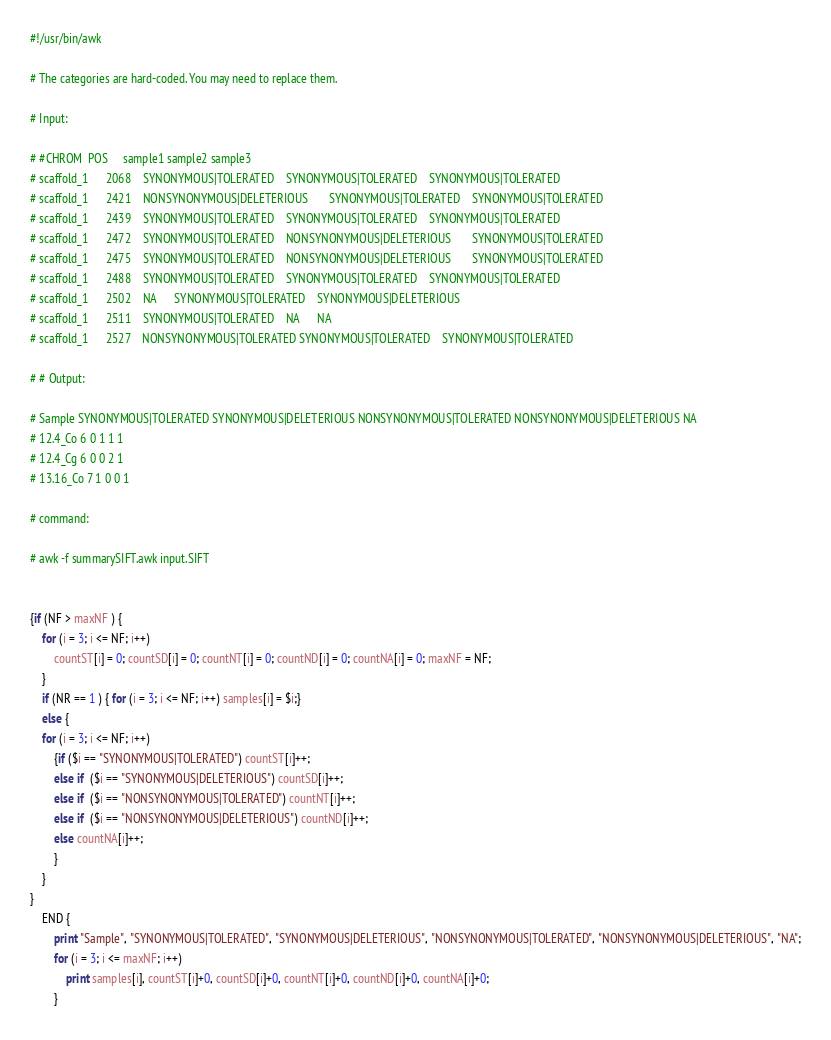<code> <loc_0><loc_0><loc_500><loc_500><_Awk_>#!/usr/bin/awk

# The categories are hard-coded. You may need to replace them.

# Input:

# #CHROM  POS     sample1 sample2 sample3
# scaffold_1      2068    SYNONYMOUS|TOLERATED    SYNONYMOUS|TOLERATED    SYNONYMOUS|TOLERATED
# scaffold_1      2421    NONSYNONYMOUS|DELETERIOUS       SYNONYMOUS|TOLERATED    SYNONYMOUS|TOLERATED
# scaffold_1      2439    SYNONYMOUS|TOLERATED    SYNONYMOUS|TOLERATED    SYNONYMOUS|TOLERATED
# scaffold_1      2472    SYNONYMOUS|TOLERATED    NONSYNONYMOUS|DELETERIOUS       SYNONYMOUS|TOLERATED
# scaffold_1      2475    SYNONYMOUS|TOLERATED    NONSYNONYMOUS|DELETERIOUS       SYNONYMOUS|TOLERATED
# scaffold_1      2488    SYNONYMOUS|TOLERATED    SYNONYMOUS|TOLERATED    SYNONYMOUS|TOLERATED
# scaffold_1      2502    NA      SYNONYMOUS|TOLERATED    SYNONYMOUS|DELETERIOUS
# scaffold_1      2511    SYNONYMOUS|TOLERATED    NA      NA
# scaffold_1      2527    NONSYNONYMOUS|TOLERATED SYNONYMOUS|TOLERATED    SYNONYMOUS|TOLERATED

# # Output:

# Sample SYNONYMOUS|TOLERATED SYNONYMOUS|DELETERIOUS NONSYNONYMOUS|TOLERATED NONSYNONYMOUS|DELETERIOUS NA
# 12.4_Co 6 0 1 1 1
# 12.4_Cg 6 0 0 2 1
# 13.16_Co 7 1 0 0 1

# command:

# awk -f summarySIFT.awk input.SIFT


{if (NF > maxNF ) {
    for (i = 3; i <= NF; i++)
        countST[i] = 0; countSD[i] = 0; countNT[i] = 0; countND[i] = 0; countNA[i] = 0; maxNF = NF;
    }
    if (NR == 1 ) { for (i = 3; i <= NF; i++) samples[i] = $i;}
    else {
    for (i = 3; i <= NF; i++)
        {if ($i == "SYNONYMOUS|TOLERATED") countST[i]++;
        else if  ($i == "SYNONYMOUS|DELETERIOUS") countSD[i]++;
        else if  ($i == "NONSYNONYMOUS|TOLERATED") countNT[i]++;
        else if  ($i == "NONSYNONYMOUS|DELETERIOUS") countND[i]++;
        else countNA[i]++;
        }
    }
}
    END {
        print "Sample", "SYNONYMOUS|TOLERATED", "SYNONYMOUS|DELETERIOUS", "NONSYNONYMOUS|TOLERATED", "NONSYNONYMOUS|DELETERIOUS", "NA";
        for (i = 3; i <= maxNF; i++)
            print samples[i], countST[i]+0, countSD[i]+0, countNT[i]+0, countND[i]+0, countNA[i]+0;
        }
</code> 